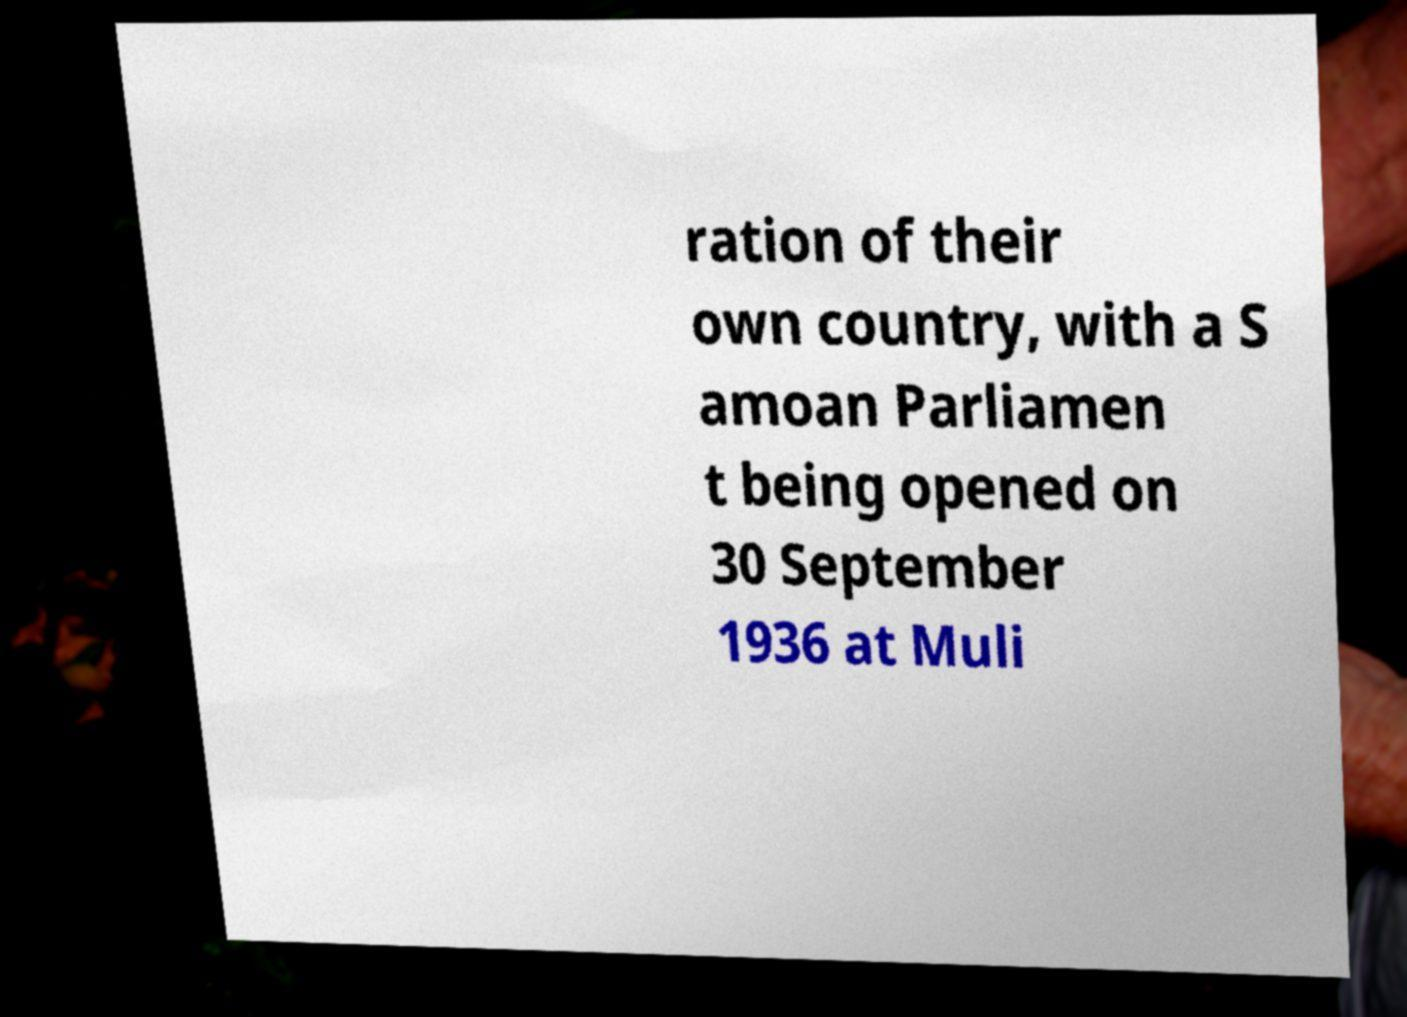What messages or text are displayed in this image? I need them in a readable, typed format. ration of their own country, with a S amoan Parliamen t being opened on 30 September 1936 at Muli 